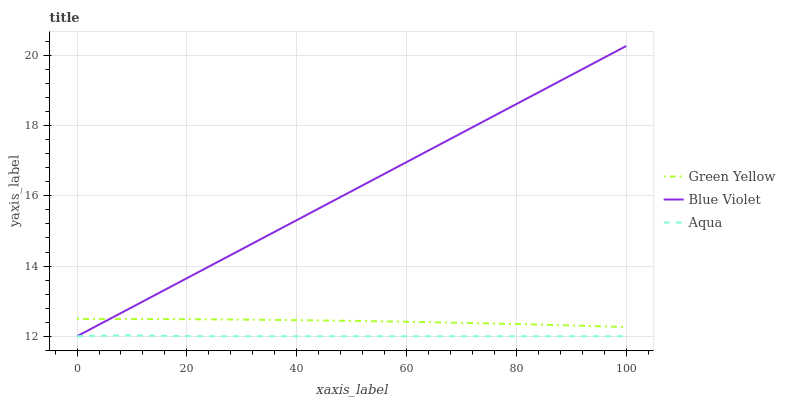Does Aqua have the minimum area under the curve?
Answer yes or no. Yes. Does Blue Violet have the maximum area under the curve?
Answer yes or no. Yes. Does Blue Violet have the minimum area under the curve?
Answer yes or no. No. Does Aqua have the maximum area under the curve?
Answer yes or no. No. Is Blue Violet the smoothest?
Answer yes or no. Yes. Is Aqua the roughest?
Answer yes or no. Yes. Is Aqua the smoothest?
Answer yes or no. No. Is Blue Violet the roughest?
Answer yes or no. No. Does Aqua have the lowest value?
Answer yes or no. Yes. Does Blue Violet have the highest value?
Answer yes or no. Yes. Does Aqua have the highest value?
Answer yes or no. No. Is Aqua less than Green Yellow?
Answer yes or no. Yes. Is Green Yellow greater than Aqua?
Answer yes or no. Yes. Does Blue Violet intersect Aqua?
Answer yes or no. Yes. Is Blue Violet less than Aqua?
Answer yes or no. No. Is Blue Violet greater than Aqua?
Answer yes or no. No. Does Aqua intersect Green Yellow?
Answer yes or no. No. 